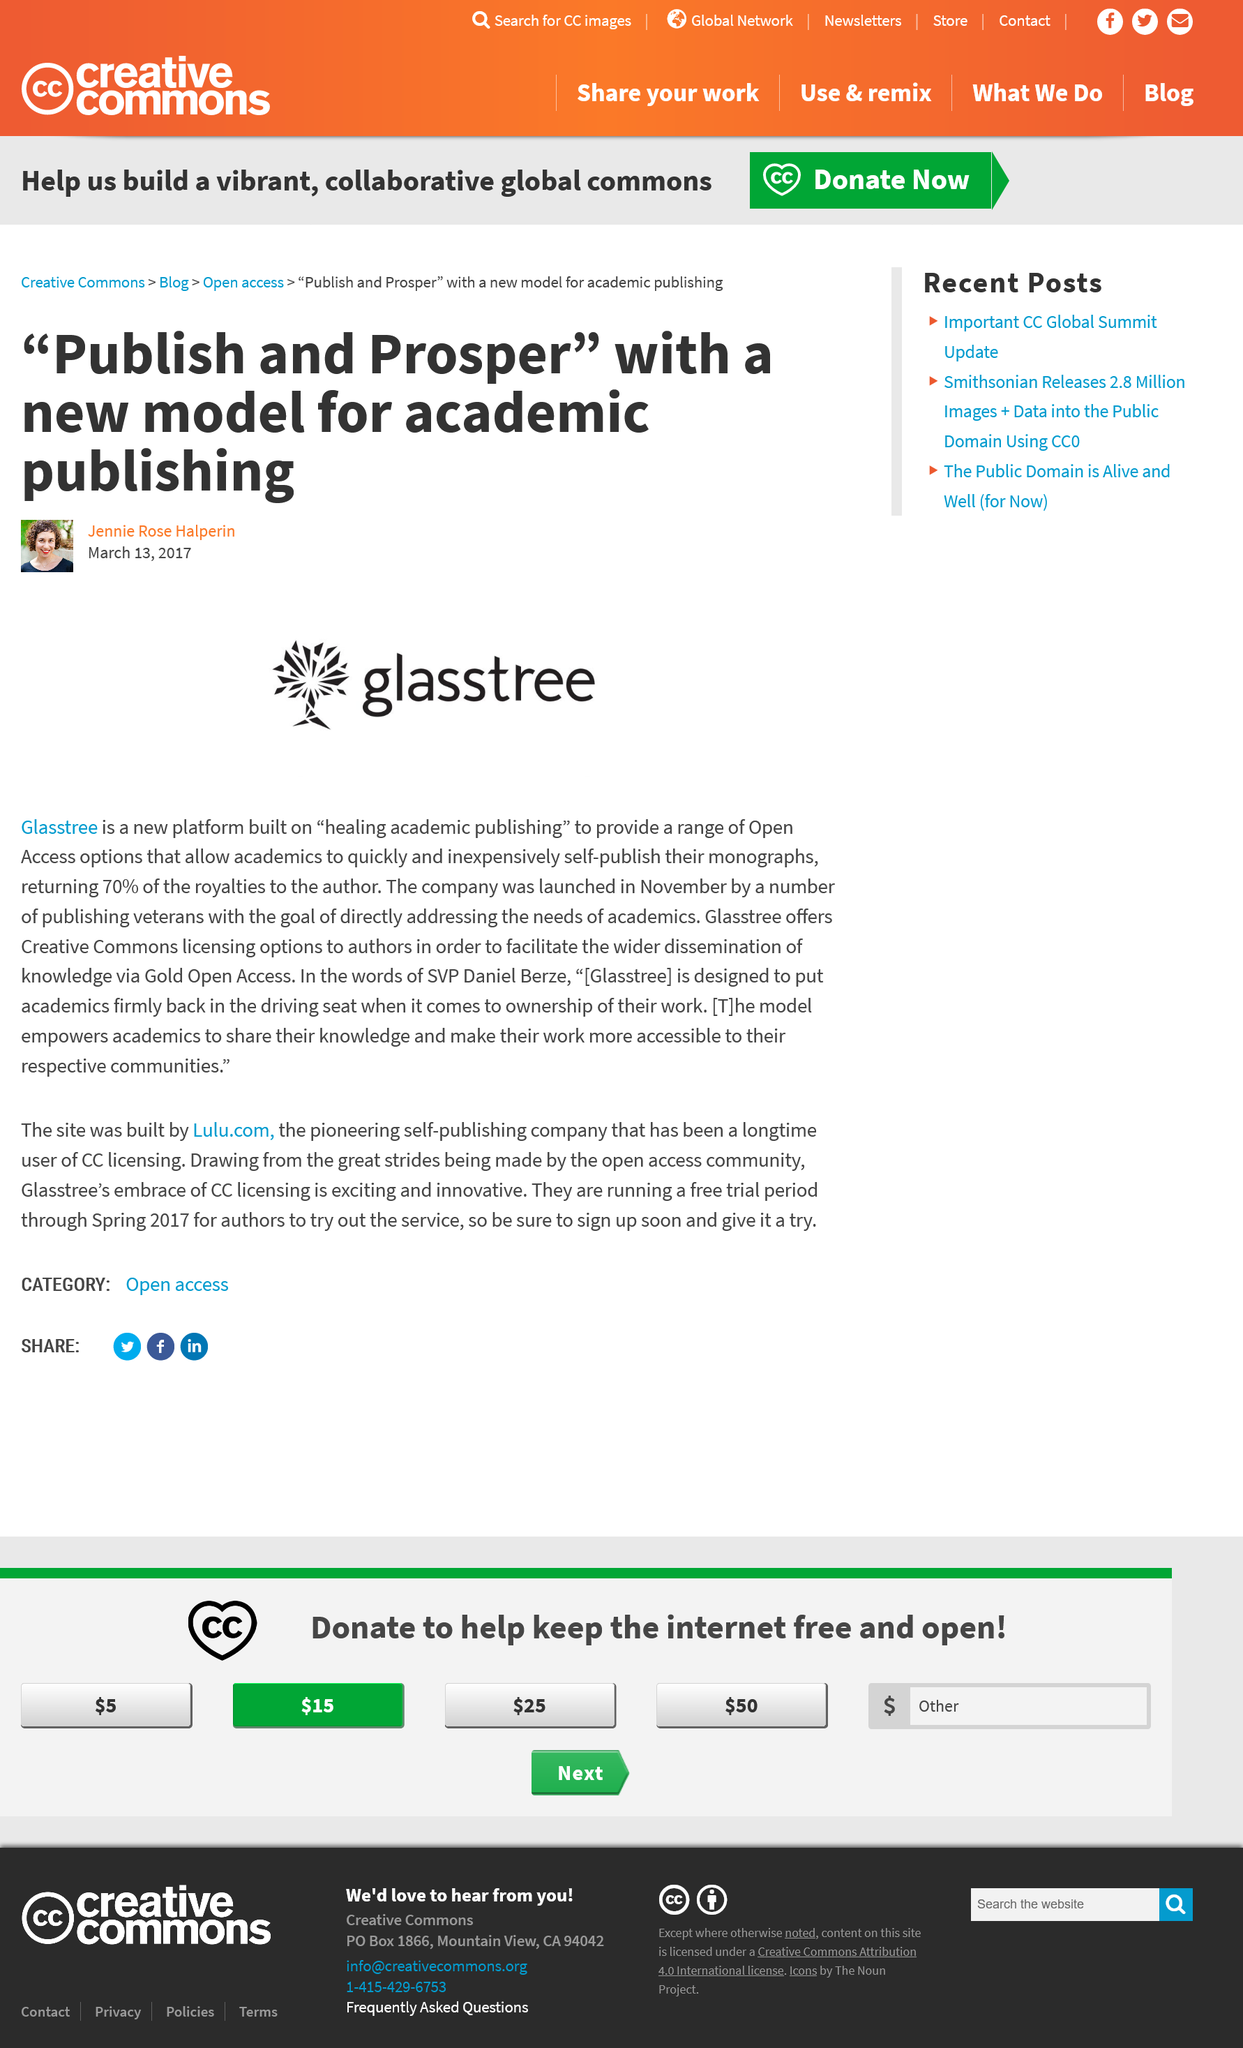List a handful of essential elements in this visual. Glasstree was launched in November. The article was written by Jennie Rose Halperin. 